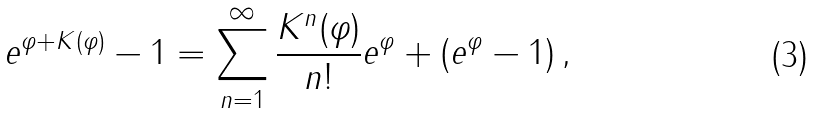Convert formula to latex. <formula><loc_0><loc_0><loc_500><loc_500>e ^ { \varphi + K ( \varphi ) } - 1 = \sum _ { n = 1 } ^ { \infty } \frac { K ^ { n } ( \varphi ) } { n ! } e ^ { \varphi } + ( e ^ { \varphi } - 1 ) \, ,</formula> 